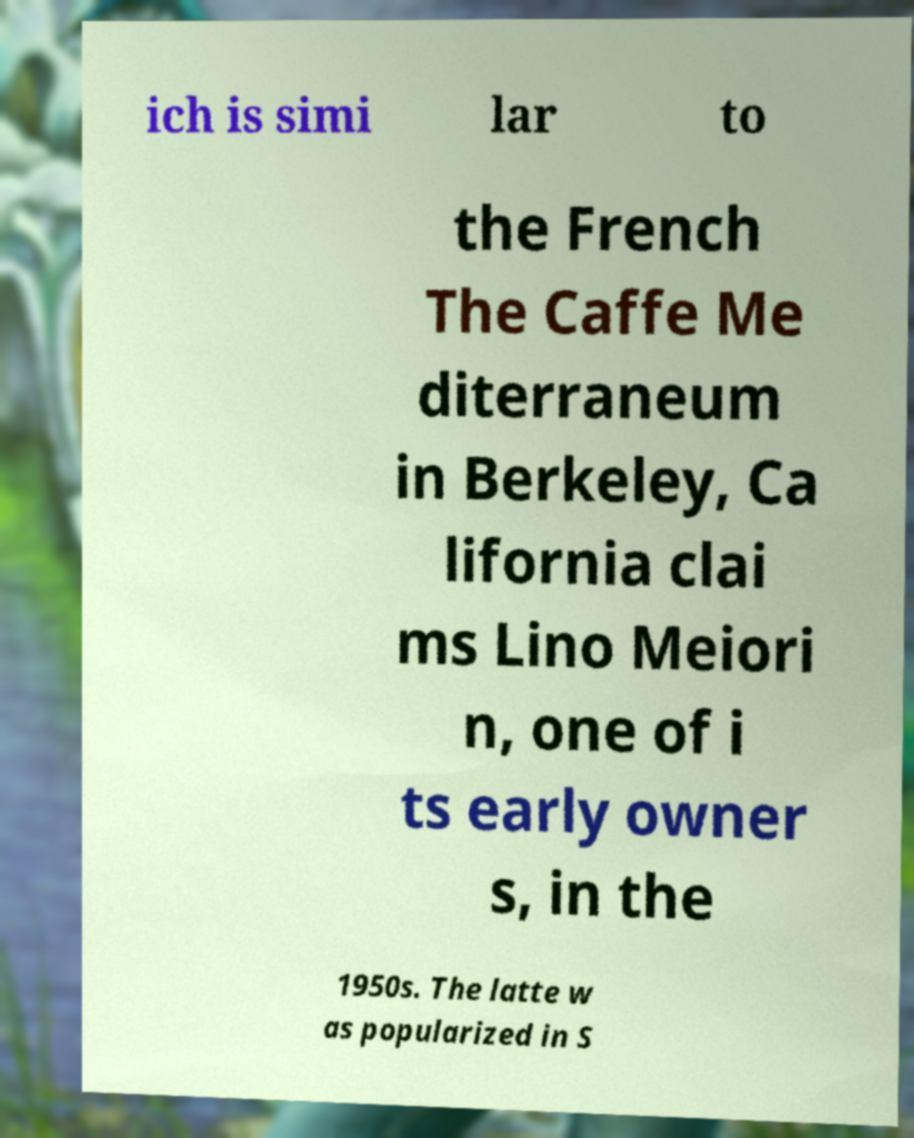Please read and relay the text visible in this image. What does it say? ich is simi lar to the French The Caffe Me diterraneum in Berkeley, Ca lifornia clai ms Lino Meiori n, one of i ts early owner s, in the 1950s. The latte w as popularized in S 